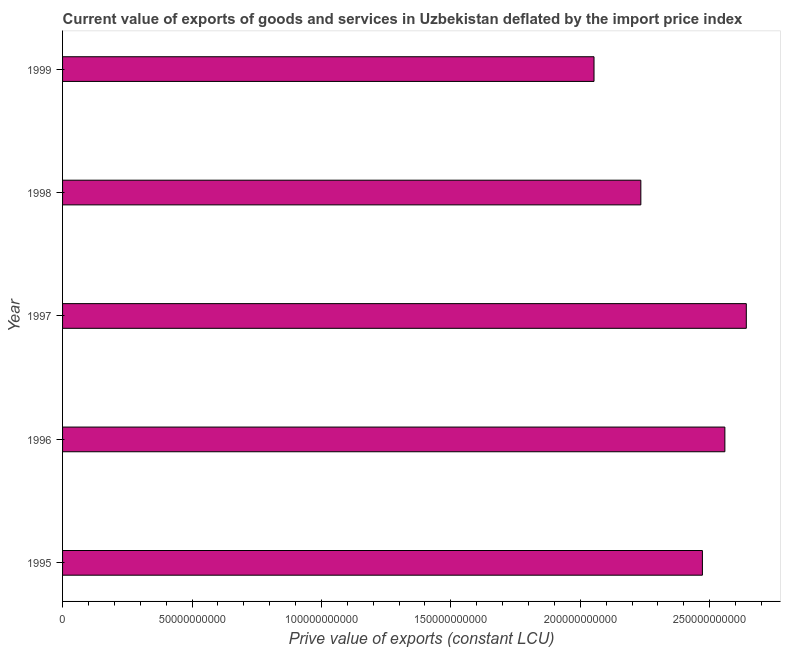Does the graph contain any zero values?
Your response must be concise. No. Does the graph contain grids?
Offer a terse response. No. What is the title of the graph?
Your response must be concise. Current value of exports of goods and services in Uzbekistan deflated by the import price index. What is the label or title of the X-axis?
Give a very brief answer. Prive value of exports (constant LCU). What is the label or title of the Y-axis?
Make the answer very short. Year. What is the price value of exports in 1998?
Offer a very short reply. 2.23e+11. Across all years, what is the maximum price value of exports?
Make the answer very short. 2.64e+11. Across all years, what is the minimum price value of exports?
Your answer should be compact. 2.05e+11. What is the sum of the price value of exports?
Your answer should be compact. 1.20e+12. What is the difference between the price value of exports in 1996 and 1999?
Your answer should be compact. 5.06e+1. What is the average price value of exports per year?
Your answer should be very brief. 2.39e+11. What is the median price value of exports?
Offer a terse response. 2.47e+11. In how many years, is the price value of exports greater than 130000000000 LCU?
Provide a succinct answer. 5. Do a majority of the years between 1995 and 1996 (inclusive) have price value of exports greater than 170000000000 LCU?
Your response must be concise. Yes. What is the ratio of the price value of exports in 1997 to that in 1998?
Your response must be concise. 1.18. What is the difference between the highest and the second highest price value of exports?
Offer a very short reply. 8.28e+09. What is the difference between the highest and the lowest price value of exports?
Your response must be concise. 5.88e+1. In how many years, is the price value of exports greater than the average price value of exports taken over all years?
Provide a succinct answer. 3. How many bars are there?
Provide a succinct answer. 5. Are all the bars in the graph horizontal?
Ensure brevity in your answer.  Yes. How many years are there in the graph?
Provide a succinct answer. 5. What is the Prive value of exports (constant LCU) of 1995?
Keep it short and to the point. 2.47e+11. What is the Prive value of exports (constant LCU) of 1996?
Give a very brief answer. 2.56e+11. What is the Prive value of exports (constant LCU) of 1997?
Your answer should be compact. 2.64e+11. What is the Prive value of exports (constant LCU) in 1998?
Provide a short and direct response. 2.23e+11. What is the Prive value of exports (constant LCU) in 1999?
Give a very brief answer. 2.05e+11. What is the difference between the Prive value of exports (constant LCU) in 1995 and 1996?
Your answer should be compact. -8.68e+09. What is the difference between the Prive value of exports (constant LCU) in 1995 and 1997?
Provide a succinct answer. -1.70e+1. What is the difference between the Prive value of exports (constant LCU) in 1995 and 1998?
Keep it short and to the point. 2.38e+1. What is the difference between the Prive value of exports (constant LCU) in 1995 and 1999?
Make the answer very short. 4.19e+1. What is the difference between the Prive value of exports (constant LCU) in 1996 and 1997?
Your response must be concise. -8.28e+09. What is the difference between the Prive value of exports (constant LCU) in 1996 and 1998?
Offer a very short reply. 3.25e+1. What is the difference between the Prive value of exports (constant LCU) in 1996 and 1999?
Make the answer very short. 5.06e+1. What is the difference between the Prive value of exports (constant LCU) in 1997 and 1998?
Offer a very short reply. 4.07e+1. What is the difference between the Prive value of exports (constant LCU) in 1997 and 1999?
Keep it short and to the point. 5.88e+1. What is the difference between the Prive value of exports (constant LCU) in 1998 and 1999?
Provide a short and direct response. 1.81e+1. What is the ratio of the Prive value of exports (constant LCU) in 1995 to that in 1996?
Provide a succinct answer. 0.97. What is the ratio of the Prive value of exports (constant LCU) in 1995 to that in 1997?
Provide a short and direct response. 0.94. What is the ratio of the Prive value of exports (constant LCU) in 1995 to that in 1998?
Ensure brevity in your answer.  1.11. What is the ratio of the Prive value of exports (constant LCU) in 1995 to that in 1999?
Your answer should be compact. 1.2. What is the ratio of the Prive value of exports (constant LCU) in 1996 to that in 1998?
Ensure brevity in your answer.  1.15. What is the ratio of the Prive value of exports (constant LCU) in 1996 to that in 1999?
Ensure brevity in your answer.  1.25. What is the ratio of the Prive value of exports (constant LCU) in 1997 to that in 1998?
Your answer should be very brief. 1.18. What is the ratio of the Prive value of exports (constant LCU) in 1997 to that in 1999?
Provide a short and direct response. 1.29. What is the ratio of the Prive value of exports (constant LCU) in 1998 to that in 1999?
Make the answer very short. 1.09. 